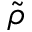Convert formula to latex. <formula><loc_0><loc_0><loc_500><loc_500>\tilde { \rho }</formula> 